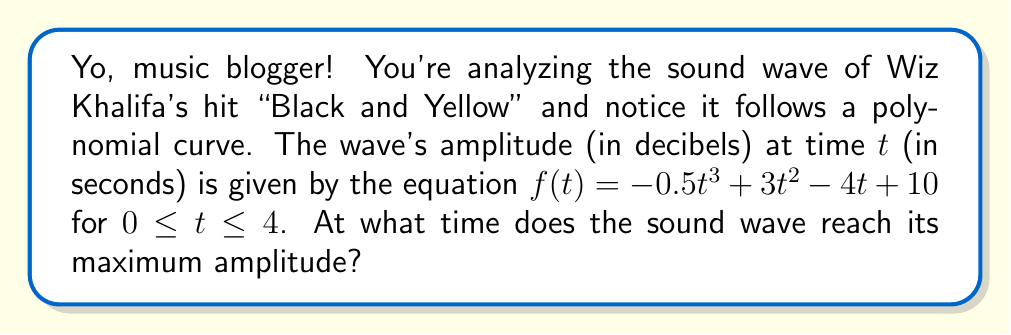Help me with this question. To find the maximum amplitude of the sound wave, we need to follow these steps:

1) The function $f(t) = -0.5t^3 + 3t^2 - 4t + 10$ represents the amplitude over time.

2) To find the maximum, we need to find where the derivative of this function equals zero.

3) The derivative is:
   $$f'(t) = -1.5t^2 + 6t - 4$$

4) Set this equal to zero:
   $$-1.5t^2 + 6t - 4 = 0$$

5) This is a quadratic equation. We can solve it using the quadratic formula:
   $$t = \frac{-b \pm \sqrt{b^2 - 4ac}}{2a}$$
   where $a = -1.5$, $b = 6$, and $c = -4$

6) Plugging in these values:
   $$t = \frac{-6 \pm \sqrt{36 - 4(-1.5)(-4)}}{2(-1.5)}$$
   $$= \frac{-6 \pm \sqrt{36 - 24}}{-3}$$
   $$= \frac{-6 \pm \sqrt{12}}{-3}$$
   $$= \frac{-6 \pm 2\sqrt{3}}{-3}$$

7) This gives us two solutions:
   $$t_1 = \frac{-6 + 2\sqrt{3}}{-3} = 2 - \frac{2\sqrt{3}}{3}$$
   $$t_2 = \frac{-6 - 2\sqrt{3}}{-3} = 2 + \frac{2\sqrt{3}}{3}$$

8) Since we're looking at the interval $0 \leq t \leq 4$, both of these solutions are valid.

9) To determine which gives the maximum, we can plug these values back into the original function or note that since the leading coefficient of the cubic function is negative, the larger t-value will give the maximum.

Therefore, the maximum occurs at $t = 2 + \frac{2\sqrt{3}}{3}$.
Answer: $2 + \frac{2\sqrt{3}}{3}$ seconds 